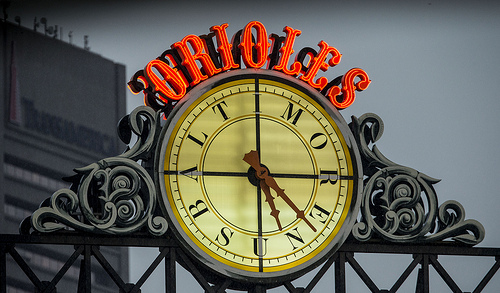How many buildings are behind the clock? It's challenging to ascertain the exact number of buildings due to the angle and focus of this photo; however, we can infer that there is at least one prominent building directly behind the clock based on its outline and the glimpse of its structure peeking from the sides. 